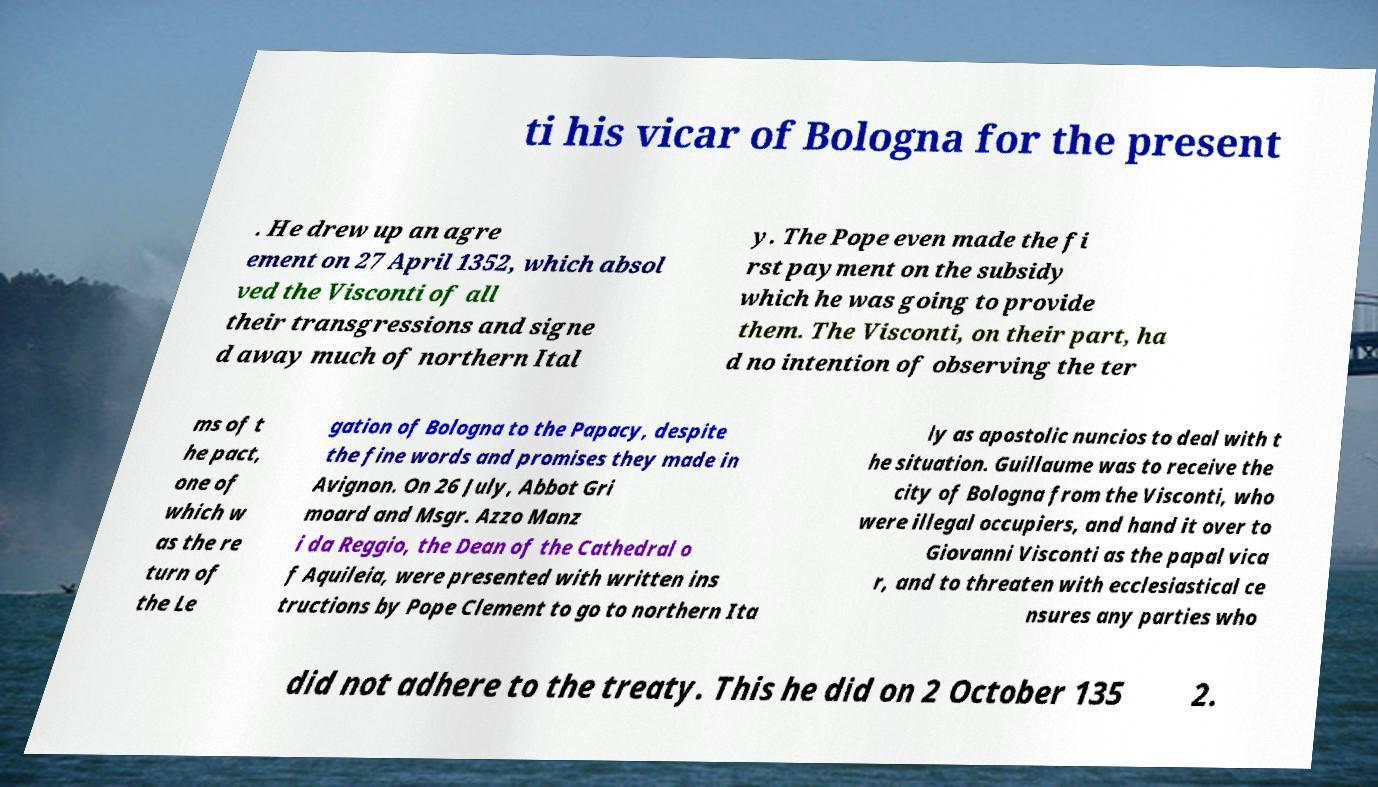I need the written content from this picture converted into text. Can you do that? ti his vicar of Bologna for the present . He drew up an agre ement on 27 April 1352, which absol ved the Visconti of all their transgressions and signe d away much of northern Ital y. The Pope even made the fi rst payment on the subsidy which he was going to provide them. The Visconti, on their part, ha d no intention of observing the ter ms of t he pact, one of which w as the re turn of the Le gation of Bologna to the Papacy, despite the fine words and promises they made in Avignon. On 26 July, Abbot Gri moard and Msgr. Azzo Manz i da Reggio, the Dean of the Cathedral o f Aquileia, were presented with written ins tructions by Pope Clement to go to northern Ita ly as apostolic nuncios to deal with t he situation. Guillaume was to receive the city of Bologna from the Visconti, who were illegal occupiers, and hand it over to Giovanni Visconti as the papal vica r, and to threaten with ecclesiastical ce nsures any parties who did not adhere to the treaty. This he did on 2 October 135 2. 